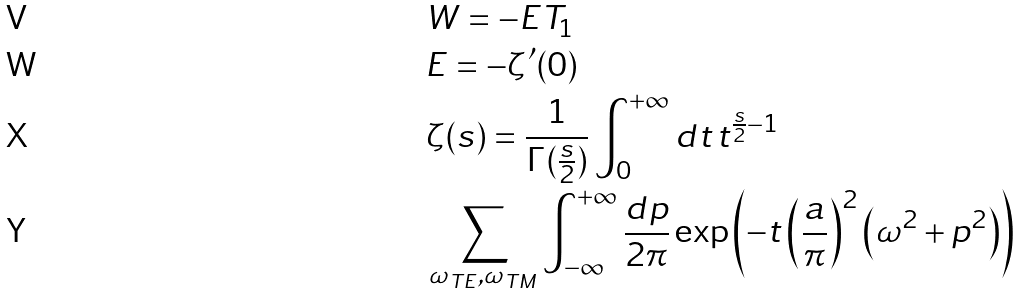<formula> <loc_0><loc_0><loc_500><loc_500>& W = - E T _ { 1 } \\ & E = - \zeta ^ { \prime } ( 0 ) \\ & \zeta ( s ) = \frac { 1 } { \Gamma ( \frac { s } { 2 } ) } \int _ { 0 } ^ { + \infty } d t \, t ^ { \frac { s } { 2 } - 1 } \\ & \sum _ { \omega _ { T E } , \omega _ { T M } } \int _ { - \infty } ^ { + \infty } \frac { d p } { 2 \pi } \exp \left ( - t \left ( \frac { a } { \pi } \right ) ^ { 2 } \left ( \omega ^ { 2 } + p ^ { 2 } \right ) \right )</formula> 